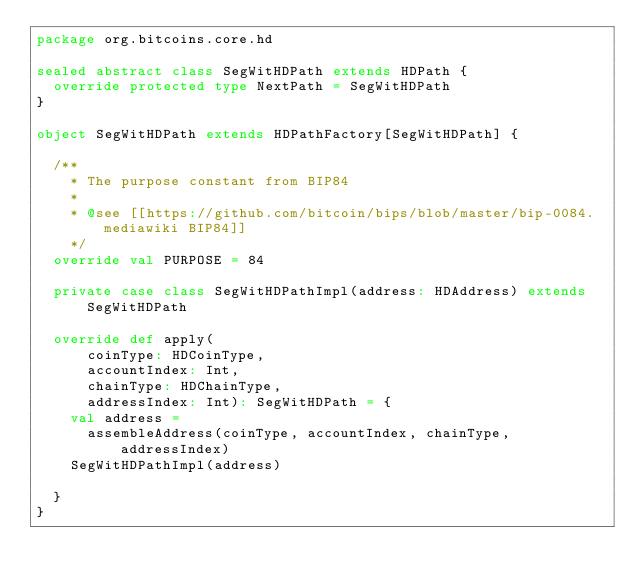Convert code to text. <code><loc_0><loc_0><loc_500><loc_500><_Scala_>package org.bitcoins.core.hd

sealed abstract class SegWitHDPath extends HDPath {
  override protected type NextPath = SegWitHDPath
}

object SegWitHDPath extends HDPathFactory[SegWitHDPath] {

  /**
    * The purpose constant from BIP84
    *
    * @see [[https://github.com/bitcoin/bips/blob/master/bip-0084.mediawiki BIP84]]
    */
  override val PURPOSE = 84

  private case class SegWitHDPathImpl(address: HDAddress) extends SegWitHDPath

  override def apply(
      coinType: HDCoinType,
      accountIndex: Int,
      chainType: HDChainType,
      addressIndex: Int): SegWitHDPath = {
    val address =
      assembleAddress(coinType, accountIndex, chainType, addressIndex)
    SegWitHDPathImpl(address)

  }
}
</code> 